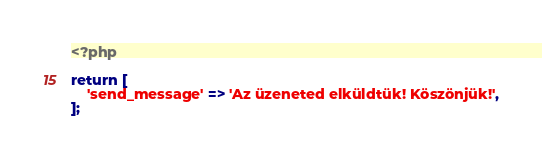<code> <loc_0><loc_0><loc_500><loc_500><_PHP_><?php

return [
    'send_message' => 'Az üzeneted elküldtük! Köszönjük!',
];</code> 